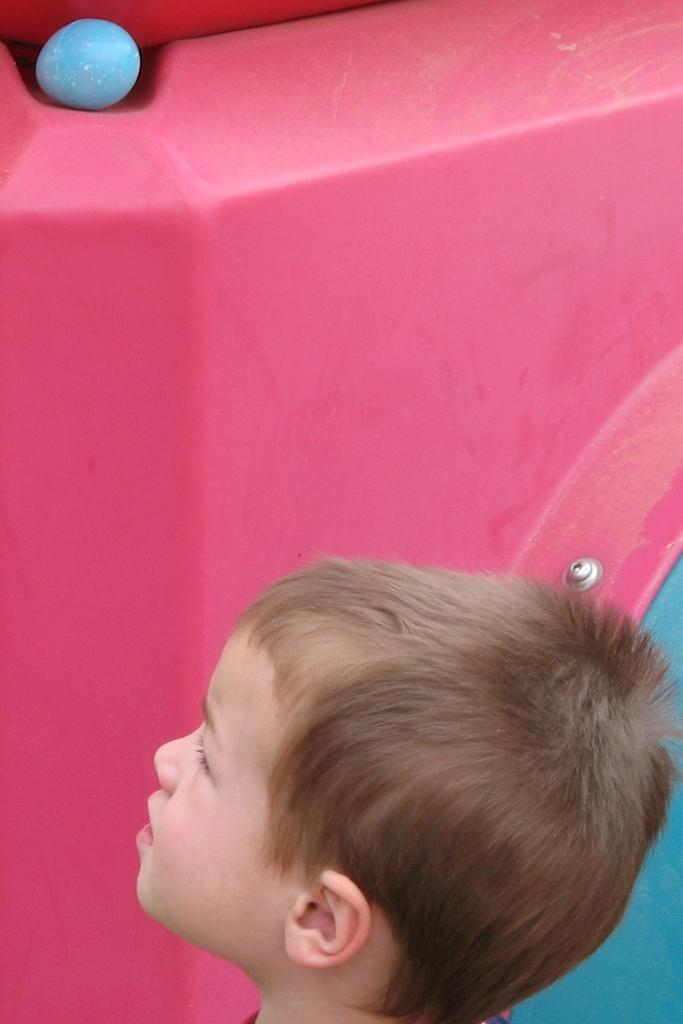What is the main subject of the image? The main subject of the image is a kid's face. Can you describe the background of the image? There is an object or area in the background with pink and blue colors. What type of insurance policy is being discussed at the party in the image? There is no mention of a party or insurance policy in the image; it only features a kid's face and a background with pink and blue colors. 